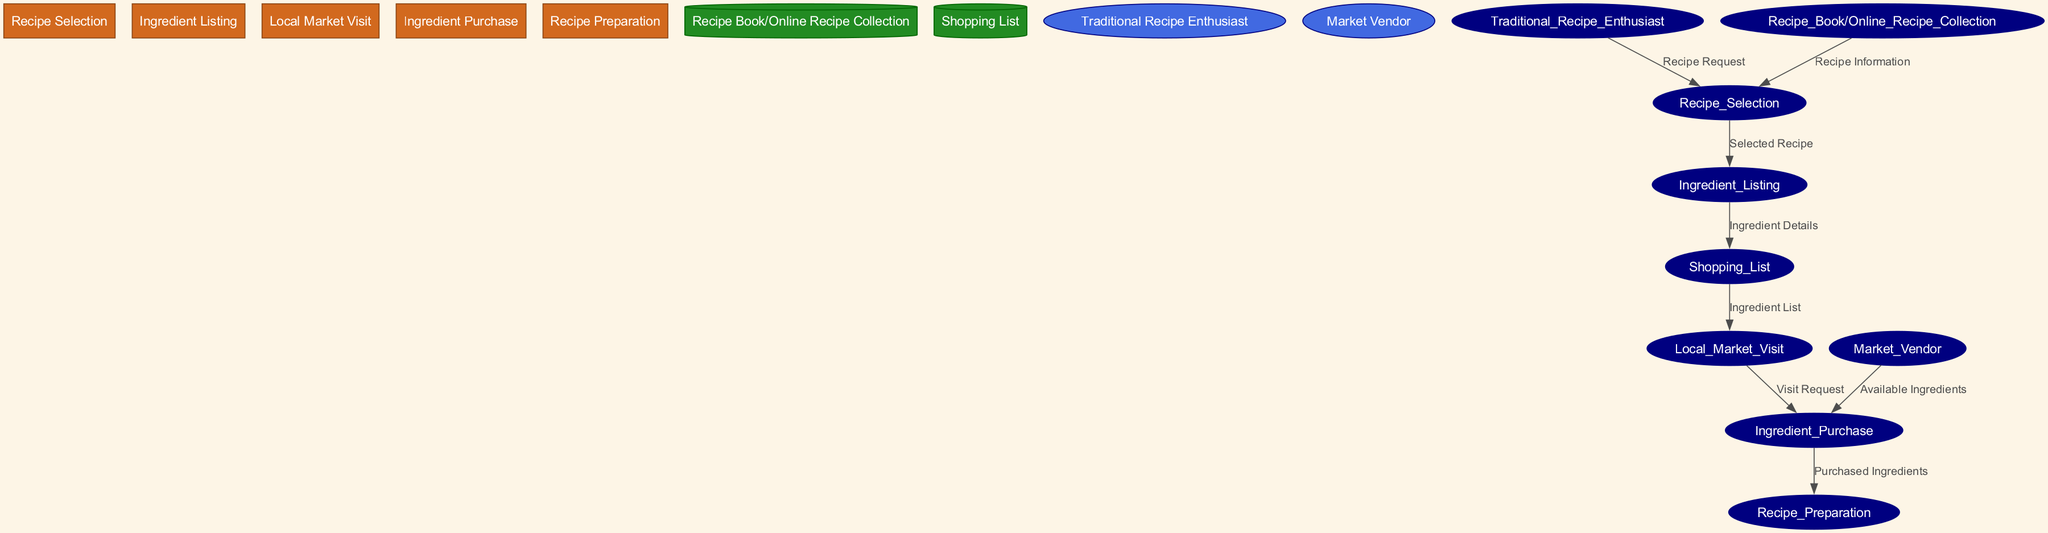What is the first process in the diagram? The first process listed in the diagram is "Recipe Selection," which is identified by the corresponding ID number and positioned at the top of the diagram.
Answer: Recipe Selection How many data stores are present in the diagram? There are two data stores in the diagram: "Recipe Book/Online Recipe Collection" and "Shopping List." This can be confirmed by counting the nodes in the data store section of the diagram.
Answer: 2 Which external entity provides information to the "Recipe Selection" process? The external entity that provides information to the "Recipe Selection" process is the "Traditional Recipe Enthusiast," as indicated by the flow of data labeled "Recipe Request."
Answer: Traditional Recipe Enthusiast What is the flow from "Ingredient Listing" to "Shopping List"? The flow from "Ingredient Listing" to "Shopping List" is labeled "Ingredient Details," which describes the transition of ingredient information from the listing process to the shopping list storage.
Answer: Ingredient Details How many processes are involved after the "Local Market Visit"? After the "Local Market Visit," there are two processes: "Ingredient Purchase" and subsequently "Recipe Preparation." This can be determined by examining the flows from the Local Market Visit node.
Answer: 2 What are the available ingredients obtained from the market vendor? The available ingredients obtained from the market vendor flow directly into the "Ingredient Purchase" process, and are described as "Available Ingredients." This indicates the nature of the transition in the flow.
Answer: Available Ingredients Which process is directly preceded by "Recipe Preparation"? The process that is directly preceded by "Recipe Preparation" is "Ingredient Purchase," as seen in the flow leading into the preparation step which utilizes the purchased ingredients.
Answer: Ingredient Purchase What is the relationship between "Ingredient Purchase" and "Recipe Preparation"? The relationship is that "Ingredient Purchase" supplies "Purchased Ingredients" to "Recipe Preparation," indicating that ingredients must be purchased before they can be used in cooking.
Answer: Purchased Ingredients Which data store informs the "Ingredient Listing" process? The "Recipe Book/Online Recipe Collection" data store informs the "Ingredient Listing" process by providing the necessary recipe information to determine the required ingredients.
Answer: Recipe Book/Online Recipe Collection 